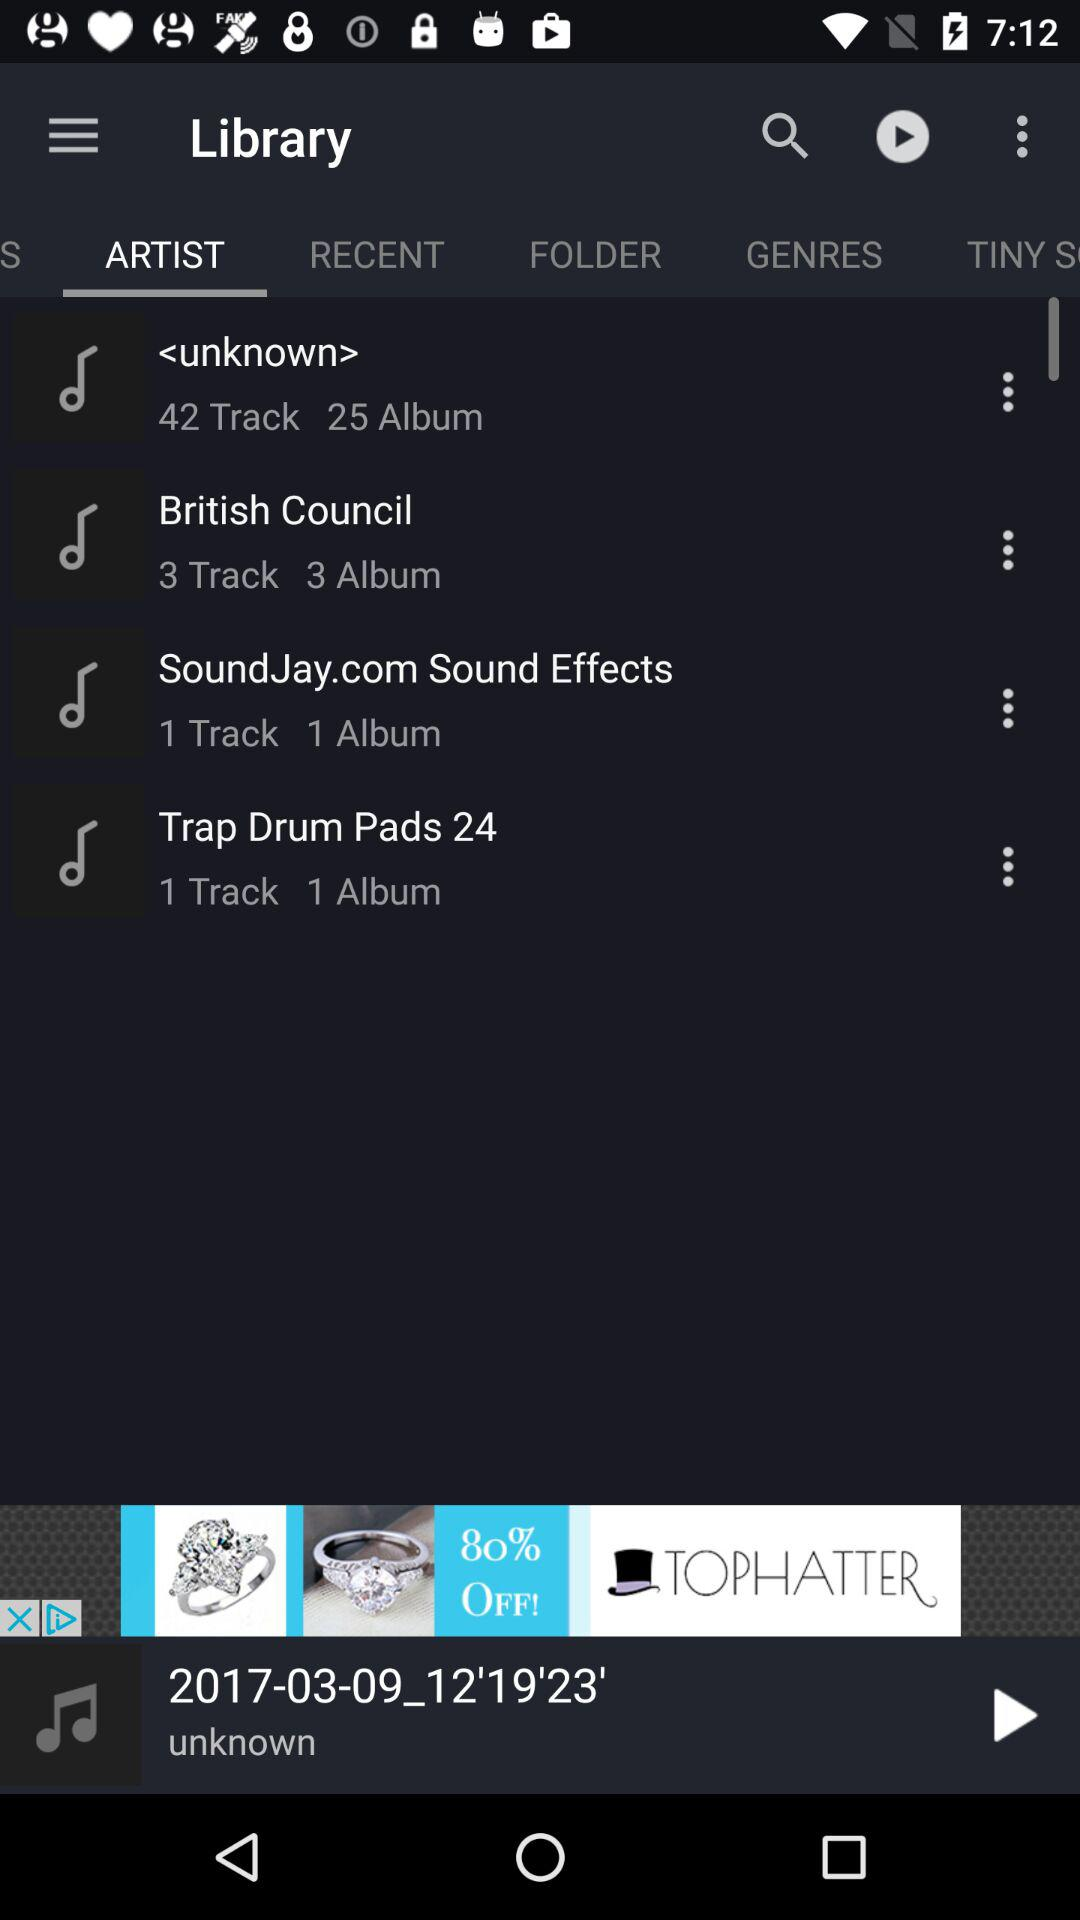Which audio is playing now? The currently playing audio is 2017-03-09_12'19'23'. 